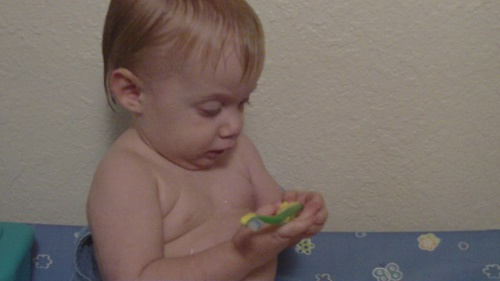Describe the objects in this image and their specific colors. I can see people in gray, brown, and maroon tones and toothbrush in gray and darkgreen tones in this image. 